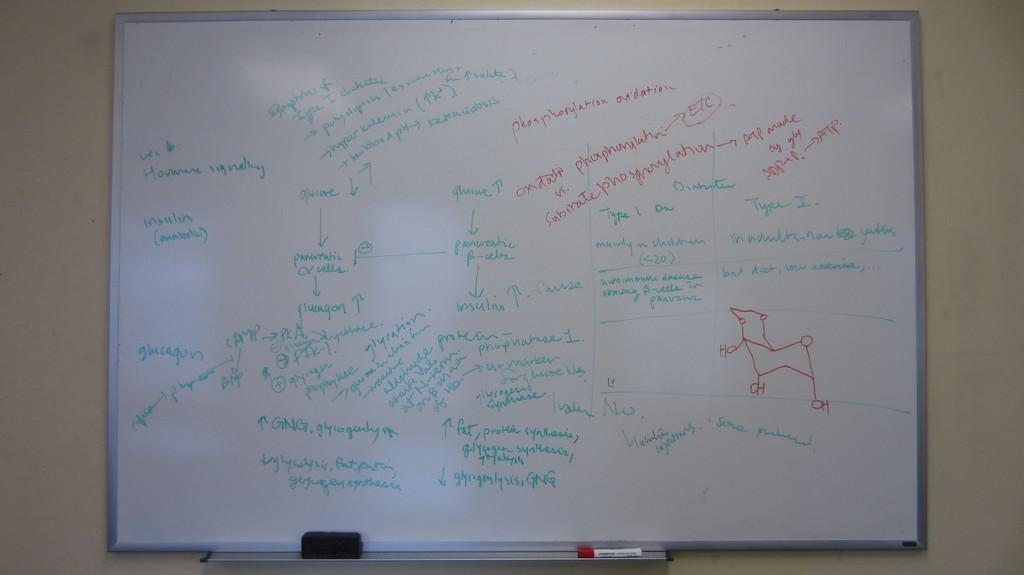Provide a one-sentence caption for the provided image. A white board with chemistry related drawing and writing such as insulin, glucagon, etc.. 